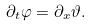<formula> <loc_0><loc_0><loc_500><loc_500>\partial _ { t } \varphi = \partial _ { x } \vartheta .</formula> 